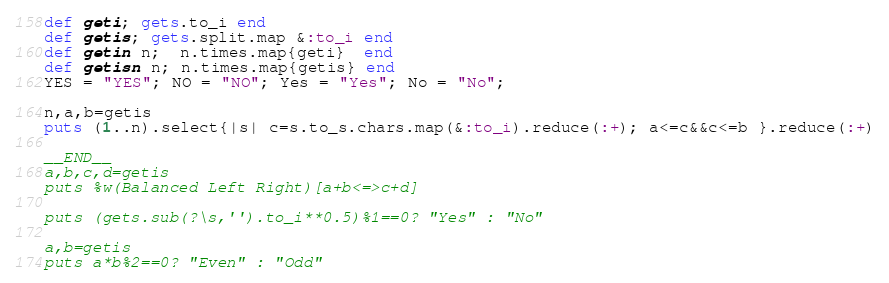Convert code to text. <code><loc_0><loc_0><loc_500><loc_500><_Ruby_>def geti; gets.to_i end
def getis; gets.split.map &:to_i end
def getin n;  n.times.map{geti}  end
def getisn n; n.times.map{getis} end
YES = "YES"; NO = "NO"; Yes = "Yes"; No = "No";

n,a,b=getis
puts (1..n).select{|s| c=s.to_s.chars.map(&:to_i).reduce(:+); a<=c&&c<=b }.reduce(:+)

__END__
a,b,c,d=getis
puts %w(Balanced Left Right)[a+b<=>c+d]

puts (gets.sub(?\s,'').to_i**0.5)%1==0? "Yes" : "No"

a,b=getis
puts a*b%2==0? "Even" : "Odd"
</code> 